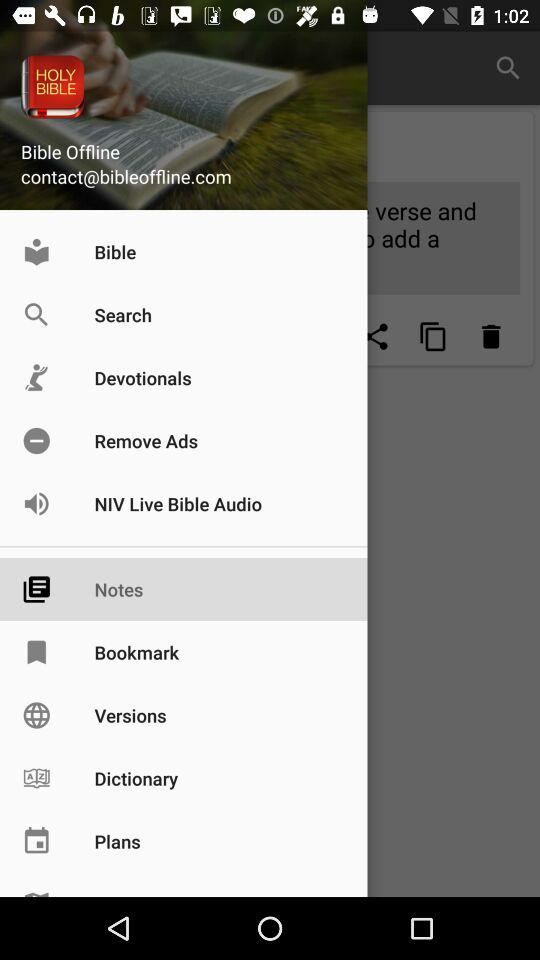What is the email address? The email address is contact@bibleoffline.com. 